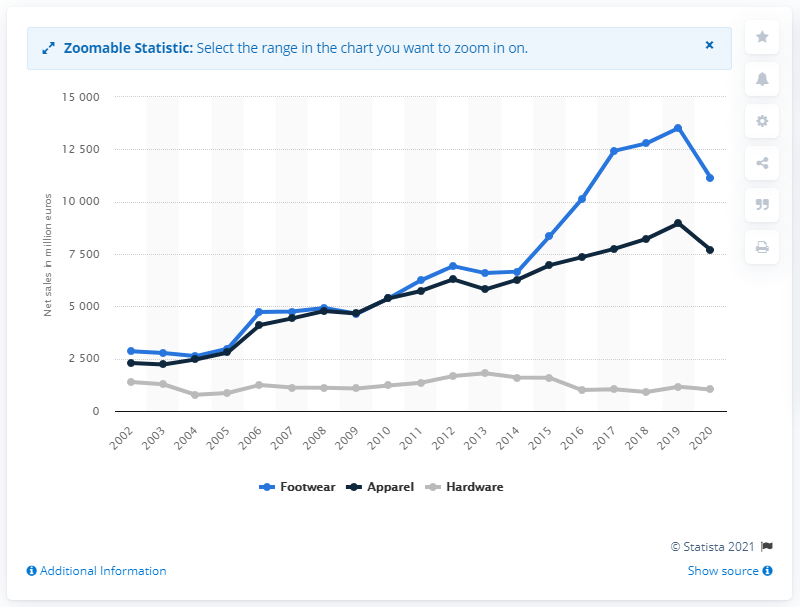List a handful of essential elements in this visual. In 2020, the global net sales of the footwear segment were 11,128. 